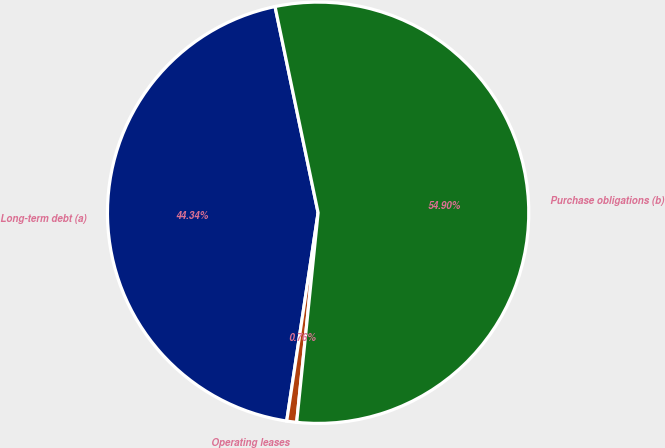Convert chart. <chart><loc_0><loc_0><loc_500><loc_500><pie_chart><fcel>Long-term debt (a)<fcel>Operating leases<fcel>Purchase obligations (b)<nl><fcel>44.34%<fcel>0.76%<fcel>54.9%<nl></chart> 